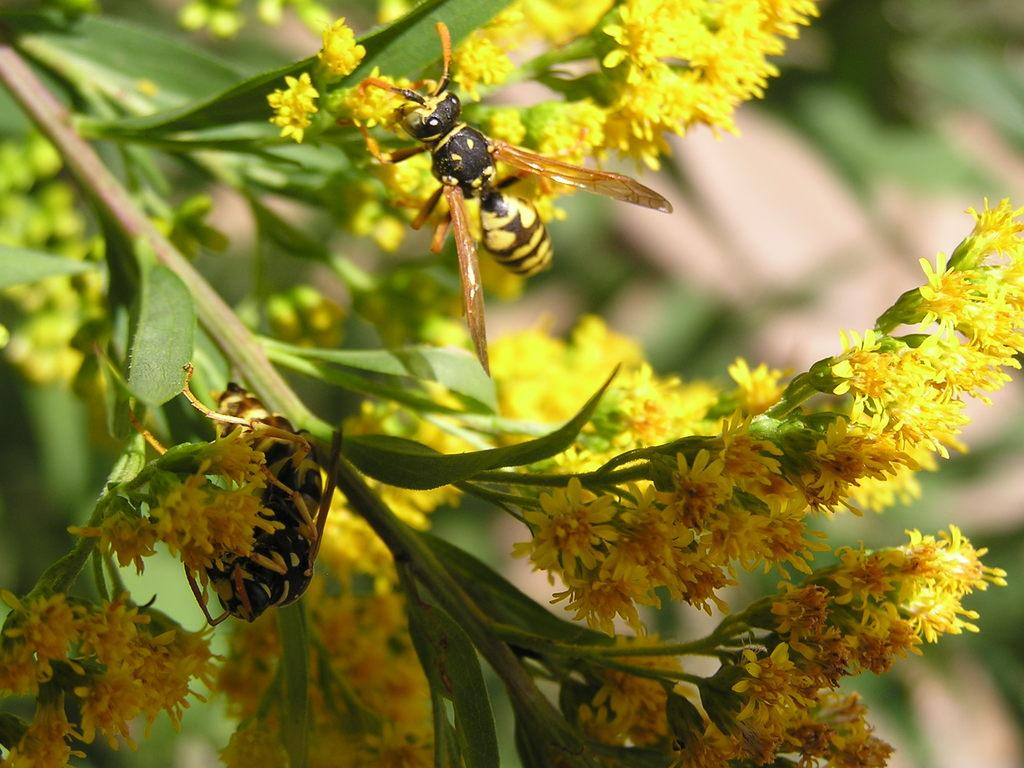What is present on the flowers in the image? There are insects on the flowers of a plant in the image. What else can be seen in the image besides the insects? There are leaves visible in the image. What type of coach can be seen in the image? There is no coach present in the image; it features insects on flowers and leaves. How does the plant stretch in the image? The plant does not stretch in the image; it is stationary with insects on its flowers and leaves. 